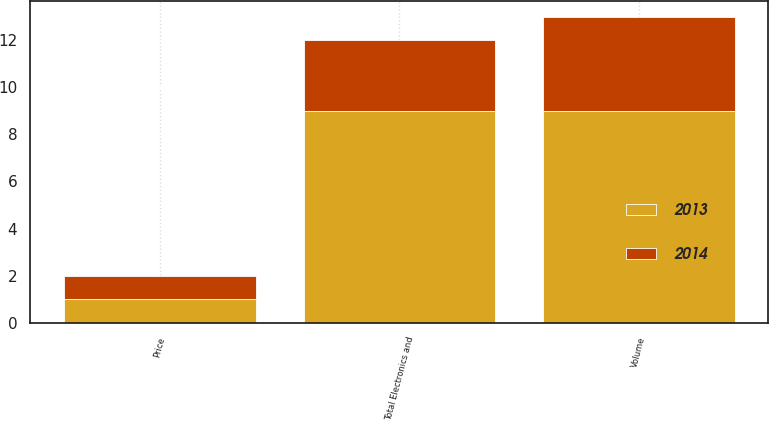Convert chart to OTSL. <chart><loc_0><loc_0><loc_500><loc_500><stacked_bar_chart><ecel><fcel>Volume<fcel>Price<fcel>Total Electronics and<nl><fcel>2013<fcel>9<fcel>1<fcel>9<nl><fcel>2014<fcel>4<fcel>1<fcel>3<nl></chart> 